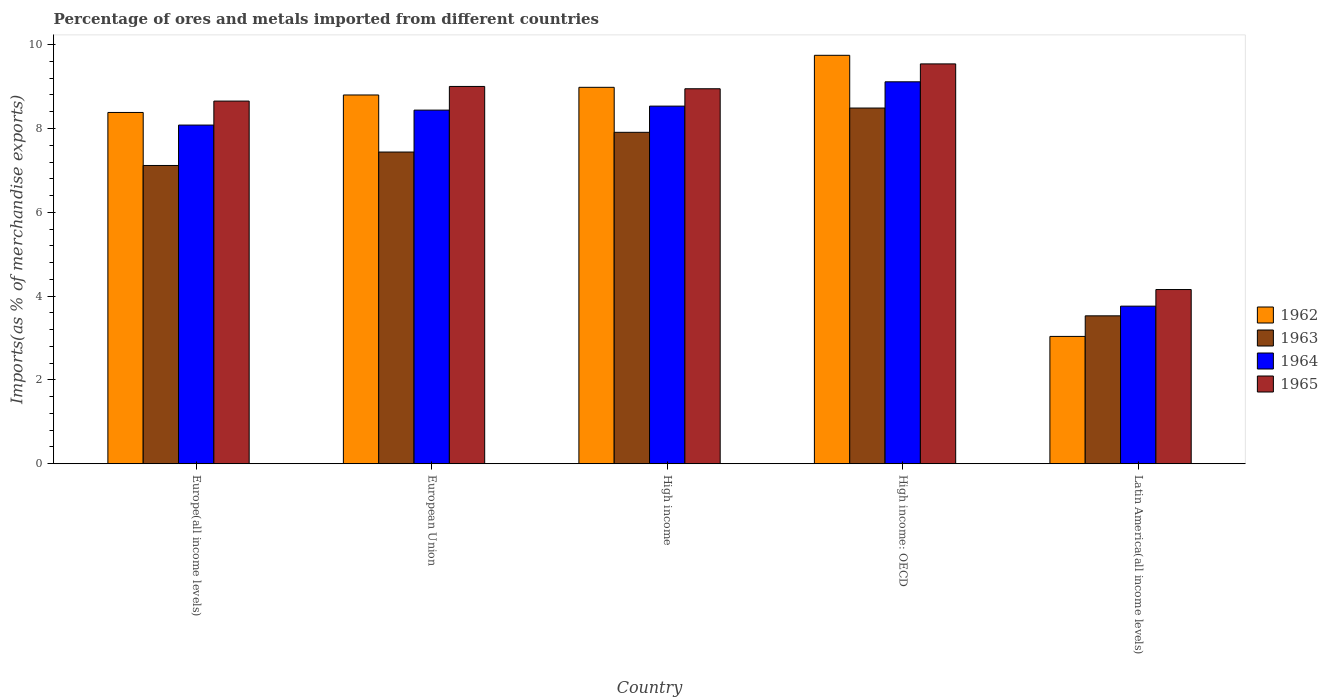How many groups of bars are there?
Offer a terse response. 5. Are the number of bars per tick equal to the number of legend labels?
Keep it short and to the point. Yes. How many bars are there on the 2nd tick from the left?
Provide a succinct answer. 4. How many bars are there on the 2nd tick from the right?
Your answer should be very brief. 4. What is the label of the 4th group of bars from the left?
Provide a succinct answer. High income: OECD. In how many cases, is the number of bars for a given country not equal to the number of legend labels?
Provide a short and direct response. 0. What is the percentage of imports to different countries in 1963 in Europe(all income levels)?
Provide a succinct answer. 7.12. Across all countries, what is the maximum percentage of imports to different countries in 1962?
Offer a terse response. 9.75. Across all countries, what is the minimum percentage of imports to different countries in 1963?
Your response must be concise. 3.53. In which country was the percentage of imports to different countries in 1965 maximum?
Make the answer very short. High income: OECD. In which country was the percentage of imports to different countries in 1963 minimum?
Keep it short and to the point. Latin America(all income levels). What is the total percentage of imports to different countries in 1962 in the graph?
Offer a terse response. 38.95. What is the difference between the percentage of imports to different countries in 1965 in European Union and that in High income: OECD?
Provide a succinct answer. -0.54. What is the difference between the percentage of imports to different countries in 1963 in Latin America(all income levels) and the percentage of imports to different countries in 1964 in European Union?
Keep it short and to the point. -4.91. What is the average percentage of imports to different countries in 1965 per country?
Offer a very short reply. 8.06. What is the difference between the percentage of imports to different countries of/in 1965 and percentage of imports to different countries of/in 1964 in Europe(all income levels)?
Offer a terse response. 0.57. In how many countries, is the percentage of imports to different countries in 1962 greater than 9.2 %?
Your answer should be very brief. 1. What is the ratio of the percentage of imports to different countries in 1963 in High income to that in High income: OECD?
Keep it short and to the point. 0.93. Is the percentage of imports to different countries in 1965 in High income: OECD less than that in Latin America(all income levels)?
Your answer should be very brief. No. Is the difference between the percentage of imports to different countries in 1965 in Europe(all income levels) and High income greater than the difference between the percentage of imports to different countries in 1964 in Europe(all income levels) and High income?
Provide a short and direct response. Yes. What is the difference between the highest and the second highest percentage of imports to different countries in 1964?
Keep it short and to the point. -0.58. What is the difference between the highest and the lowest percentage of imports to different countries in 1964?
Provide a short and direct response. 5.35. In how many countries, is the percentage of imports to different countries in 1962 greater than the average percentage of imports to different countries in 1962 taken over all countries?
Give a very brief answer. 4. Is it the case that in every country, the sum of the percentage of imports to different countries in 1965 and percentage of imports to different countries in 1964 is greater than the sum of percentage of imports to different countries in 1963 and percentage of imports to different countries in 1962?
Give a very brief answer. No. What does the 4th bar from the left in High income: OECD represents?
Ensure brevity in your answer.  1965. What does the 3rd bar from the right in Latin America(all income levels) represents?
Your response must be concise. 1963. Is it the case that in every country, the sum of the percentage of imports to different countries in 1963 and percentage of imports to different countries in 1965 is greater than the percentage of imports to different countries in 1962?
Provide a succinct answer. Yes. How many bars are there?
Give a very brief answer. 20. Are all the bars in the graph horizontal?
Ensure brevity in your answer.  No. How many countries are there in the graph?
Make the answer very short. 5. What is the difference between two consecutive major ticks on the Y-axis?
Offer a terse response. 2. Does the graph contain grids?
Ensure brevity in your answer.  No. Where does the legend appear in the graph?
Offer a very short reply. Center right. How are the legend labels stacked?
Your answer should be compact. Vertical. What is the title of the graph?
Make the answer very short. Percentage of ores and metals imported from different countries. Does "1990" appear as one of the legend labels in the graph?
Provide a short and direct response. No. What is the label or title of the Y-axis?
Offer a very short reply. Imports(as % of merchandise exports). What is the Imports(as % of merchandise exports) in 1962 in Europe(all income levels)?
Keep it short and to the point. 8.38. What is the Imports(as % of merchandise exports) of 1963 in Europe(all income levels)?
Your answer should be very brief. 7.12. What is the Imports(as % of merchandise exports) of 1964 in Europe(all income levels)?
Offer a very short reply. 8.08. What is the Imports(as % of merchandise exports) in 1965 in Europe(all income levels)?
Offer a very short reply. 8.65. What is the Imports(as % of merchandise exports) in 1962 in European Union?
Ensure brevity in your answer.  8.8. What is the Imports(as % of merchandise exports) of 1963 in European Union?
Give a very brief answer. 7.44. What is the Imports(as % of merchandise exports) of 1964 in European Union?
Provide a succinct answer. 8.44. What is the Imports(as % of merchandise exports) in 1965 in European Union?
Make the answer very short. 9. What is the Imports(as % of merchandise exports) in 1962 in High income?
Your response must be concise. 8.98. What is the Imports(as % of merchandise exports) in 1963 in High income?
Ensure brevity in your answer.  7.91. What is the Imports(as % of merchandise exports) of 1964 in High income?
Provide a succinct answer. 8.53. What is the Imports(as % of merchandise exports) in 1965 in High income?
Keep it short and to the point. 8.95. What is the Imports(as % of merchandise exports) of 1962 in High income: OECD?
Keep it short and to the point. 9.75. What is the Imports(as % of merchandise exports) of 1963 in High income: OECD?
Keep it short and to the point. 8.49. What is the Imports(as % of merchandise exports) of 1964 in High income: OECD?
Offer a terse response. 9.11. What is the Imports(as % of merchandise exports) in 1965 in High income: OECD?
Provide a short and direct response. 9.54. What is the Imports(as % of merchandise exports) in 1962 in Latin America(all income levels)?
Provide a short and direct response. 3.04. What is the Imports(as % of merchandise exports) in 1963 in Latin America(all income levels)?
Make the answer very short. 3.53. What is the Imports(as % of merchandise exports) of 1964 in Latin America(all income levels)?
Provide a succinct answer. 3.76. What is the Imports(as % of merchandise exports) in 1965 in Latin America(all income levels)?
Your answer should be very brief. 4.16. Across all countries, what is the maximum Imports(as % of merchandise exports) of 1962?
Offer a very short reply. 9.75. Across all countries, what is the maximum Imports(as % of merchandise exports) of 1963?
Offer a terse response. 8.49. Across all countries, what is the maximum Imports(as % of merchandise exports) in 1964?
Offer a terse response. 9.11. Across all countries, what is the maximum Imports(as % of merchandise exports) in 1965?
Make the answer very short. 9.54. Across all countries, what is the minimum Imports(as % of merchandise exports) of 1962?
Provide a succinct answer. 3.04. Across all countries, what is the minimum Imports(as % of merchandise exports) of 1963?
Provide a succinct answer. 3.53. Across all countries, what is the minimum Imports(as % of merchandise exports) in 1964?
Your response must be concise. 3.76. Across all countries, what is the minimum Imports(as % of merchandise exports) of 1965?
Provide a short and direct response. 4.16. What is the total Imports(as % of merchandise exports) of 1962 in the graph?
Provide a short and direct response. 38.95. What is the total Imports(as % of merchandise exports) in 1963 in the graph?
Make the answer very short. 34.48. What is the total Imports(as % of merchandise exports) of 1964 in the graph?
Provide a succinct answer. 37.93. What is the total Imports(as % of merchandise exports) of 1965 in the graph?
Offer a very short reply. 40.31. What is the difference between the Imports(as % of merchandise exports) of 1962 in Europe(all income levels) and that in European Union?
Keep it short and to the point. -0.42. What is the difference between the Imports(as % of merchandise exports) in 1963 in Europe(all income levels) and that in European Union?
Ensure brevity in your answer.  -0.32. What is the difference between the Imports(as % of merchandise exports) of 1964 in Europe(all income levels) and that in European Union?
Provide a short and direct response. -0.36. What is the difference between the Imports(as % of merchandise exports) in 1965 in Europe(all income levels) and that in European Union?
Keep it short and to the point. -0.35. What is the difference between the Imports(as % of merchandise exports) in 1962 in Europe(all income levels) and that in High income?
Offer a very short reply. -0.6. What is the difference between the Imports(as % of merchandise exports) of 1963 in Europe(all income levels) and that in High income?
Ensure brevity in your answer.  -0.79. What is the difference between the Imports(as % of merchandise exports) in 1964 in Europe(all income levels) and that in High income?
Offer a terse response. -0.45. What is the difference between the Imports(as % of merchandise exports) in 1965 in Europe(all income levels) and that in High income?
Provide a short and direct response. -0.29. What is the difference between the Imports(as % of merchandise exports) of 1962 in Europe(all income levels) and that in High income: OECD?
Your answer should be compact. -1.36. What is the difference between the Imports(as % of merchandise exports) in 1963 in Europe(all income levels) and that in High income: OECD?
Provide a succinct answer. -1.37. What is the difference between the Imports(as % of merchandise exports) of 1964 in Europe(all income levels) and that in High income: OECD?
Provide a succinct answer. -1.03. What is the difference between the Imports(as % of merchandise exports) of 1965 in Europe(all income levels) and that in High income: OECD?
Keep it short and to the point. -0.89. What is the difference between the Imports(as % of merchandise exports) of 1962 in Europe(all income levels) and that in Latin America(all income levels)?
Give a very brief answer. 5.34. What is the difference between the Imports(as % of merchandise exports) in 1963 in Europe(all income levels) and that in Latin America(all income levels)?
Make the answer very short. 3.59. What is the difference between the Imports(as % of merchandise exports) in 1964 in Europe(all income levels) and that in Latin America(all income levels)?
Give a very brief answer. 4.32. What is the difference between the Imports(as % of merchandise exports) in 1965 in Europe(all income levels) and that in Latin America(all income levels)?
Provide a succinct answer. 4.5. What is the difference between the Imports(as % of merchandise exports) in 1962 in European Union and that in High income?
Keep it short and to the point. -0.18. What is the difference between the Imports(as % of merchandise exports) in 1963 in European Union and that in High income?
Give a very brief answer. -0.47. What is the difference between the Imports(as % of merchandise exports) in 1964 in European Union and that in High income?
Offer a very short reply. -0.1. What is the difference between the Imports(as % of merchandise exports) in 1965 in European Union and that in High income?
Make the answer very short. 0.06. What is the difference between the Imports(as % of merchandise exports) of 1962 in European Union and that in High income: OECD?
Offer a very short reply. -0.95. What is the difference between the Imports(as % of merchandise exports) in 1963 in European Union and that in High income: OECD?
Offer a terse response. -1.05. What is the difference between the Imports(as % of merchandise exports) in 1964 in European Union and that in High income: OECD?
Make the answer very short. -0.68. What is the difference between the Imports(as % of merchandise exports) in 1965 in European Union and that in High income: OECD?
Give a very brief answer. -0.54. What is the difference between the Imports(as % of merchandise exports) of 1962 in European Union and that in Latin America(all income levels)?
Make the answer very short. 5.76. What is the difference between the Imports(as % of merchandise exports) in 1963 in European Union and that in Latin America(all income levels)?
Make the answer very short. 3.91. What is the difference between the Imports(as % of merchandise exports) of 1964 in European Union and that in Latin America(all income levels)?
Offer a very short reply. 4.68. What is the difference between the Imports(as % of merchandise exports) in 1965 in European Union and that in Latin America(all income levels)?
Ensure brevity in your answer.  4.85. What is the difference between the Imports(as % of merchandise exports) of 1962 in High income and that in High income: OECD?
Your answer should be very brief. -0.76. What is the difference between the Imports(as % of merchandise exports) in 1963 in High income and that in High income: OECD?
Your answer should be compact. -0.58. What is the difference between the Imports(as % of merchandise exports) in 1964 in High income and that in High income: OECD?
Keep it short and to the point. -0.58. What is the difference between the Imports(as % of merchandise exports) of 1965 in High income and that in High income: OECD?
Offer a terse response. -0.59. What is the difference between the Imports(as % of merchandise exports) in 1962 in High income and that in Latin America(all income levels)?
Keep it short and to the point. 5.94. What is the difference between the Imports(as % of merchandise exports) of 1963 in High income and that in Latin America(all income levels)?
Make the answer very short. 4.38. What is the difference between the Imports(as % of merchandise exports) in 1964 in High income and that in Latin America(all income levels)?
Give a very brief answer. 4.77. What is the difference between the Imports(as % of merchandise exports) in 1965 in High income and that in Latin America(all income levels)?
Make the answer very short. 4.79. What is the difference between the Imports(as % of merchandise exports) in 1962 in High income: OECD and that in Latin America(all income levels)?
Your answer should be very brief. 6.71. What is the difference between the Imports(as % of merchandise exports) in 1963 in High income: OECD and that in Latin America(all income levels)?
Your response must be concise. 4.96. What is the difference between the Imports(as % of merchandise exports) of 1964 in High income: OECD and that in Latin America(all income levels)?
Your response must be concise. 5.35. What is the difference between the Imports(as % of merchandise exports) of 1965 in High income: OECD and that in Latin America(all income levels)?
Keep it short and to the point. 5.38. What is the difference between the Imports(as % of merchandise exports) in 1962 in Europe(all income levels) and the Imports(as % of merchandise exports) in 1963 in European Union?
Keep it short and to the point. 0.94. What is the difference between the Imports(as % of merchandise exports) in 1962 in Europe(all income levels) and the Imports(as % of merchandise exports) in 1964 in European Union?
Provide a succinct answer. -0.06. What is the difference between the Imports(as % of merchandise exports) of 1962 in Europe(all income levels) and the Imports(as % of merchandise exports) of 1965 in European Union?
Your answer should be very brief. -0.62. What is the difference between the Imports(as % of merchandise exports) of 1963 in Europe(all income levels) and the Imports(as % of merchandise exports) of 1964 in European Union?
Ensure brevity in your answer.  -1.32. What is the difference between the Imports(as % of merchandise exports) in 1963 in Europe(all income levels) and the Imports(as % of merchandise exports) in 1965 in European Union?
Your response must be concise. -1.89. What is the difference between the Imports(as % of merchandise exports) of 1964 in Europe(all income levels) and the Imports(as % of merchandise exports) of 1965 in European Union?
Provide a succinct answer. -0.92. What is the difference between the Imports(as % of merchandise exports) of 1962 in Europe(all income levels) and the Imports(as % of merchandise exports) of 1963 in High income?
Your answer should be compact. 0.47. What is the difference between the Imports(as % of merchandise exports) in 1962 in Europe(all income levels) and the Imports(as % of merchandise exports) in 1964 in High income?
Keep it short and to the point. -0.15. What is the difference between the Imports(as % of merchandise exports) of 1962 in Europe(all income levels) and the Imports(as % of merchandise exports) of 1965 in High income?
Provide a succinct answer. -0.57. What is the difference between the Imports(as % of merchandise exports) in 1963 in Europe(all income levels) and the Imports(as % of merchandise exports) in 1964 in High income?
Ensure brevity in your answer.  -1.42. What is the difference between the Imports(as % of merchandise exports) of 1963 in Europe(all income levels) and the Imports(as % of merchandise exports) of 1965 in High income?
Offer a very short reply. -1.83. What is the difference between the Imports(as % of merchandise exports) of 1964 in Europe(all income levels) and the Imports(as % of merchandise exports) of 1965 in High income?
Give a very brief answer. -0.87. What is the difference between the Imports(as % of merchandise exports) in 1962 in Europe(all income levels) and the Imports(as % of merchandise exports) in 1963 in High income: OECD?
Your answer should be compact. -0.11. What is the difference between the Imports(as % of merchandise exports) of 1962 in Europe(all income levels) and the Imports(as % of merchandise exports) of 1964 in High income: OECD?
Make the answer very short. -0.73. What is the difference between the Imports(as % of merchandise exports) in 1962 in Europe(all income levels) and the Imports(as % of merchandise exports) in 1965 in High income: OECD?
Provide a short and direct response. -1.16. What is the difference between the Imports(as % of merchandise exports) of 1963 in Europe(all income levels) and the Imports(as % of merchandise exports) of 1964 in High income: OECD?
Provide a succinct answer. -2. What is the difference between the Imports(as % of merchandise exports) in 1963 in Europe(all income levels) and the Imports(as % of merchandise exports) in 1965 in High income: OECD?
Make the answer very short. -2.42. What is the difference between the Imports(as % of merchandise exports) in 1964 in Europe(all income levels) and the Imports(as % of merchandise exports) in 1965 in High income: OECD?
Your answer should be very brief. -1.46. What is the difference between the Imports(as % of merchandise exports) in 1962 in Europe(all income levels) and the Imports(as % of merchandise exports) in 1963 in Latin America(all income levels)?
Give a very brief answer. 4.85. What is the difference between the Imports(as % of merchandise exports) in 1962 in Europe(all income levels) and the Imports(as % of merchandise exports) in 1964 in Latin America(all income levels)?
Ensure brevity in your answer.  4.62. What is the difference between the Imports(as % of merchandise exports) in 1962 in Europe(all income levels) and the Imports(as % of merchandise exports) in 1965 in Latin America(all income levels)?
Your response must be concise. 4.23. What is the difference between the Imports(as % of merchandise exports) in 1963 in Europe(all income levels) and the Imports(as % of merchandise exports) in 1964 in Latin America(all income levels)?
Your answer should be compact. 3.36. What is the difference between the Imports(as % of merchandise exports) of 1963 in Europe(all income levels) and the Imports(as % of merchandise exports) of 1965 in Latin America(all income levels)?
Make the answer very short. 2.96. What is the difference between the Imports(as % of merchandise exports) of 1964 in Europe(all income levels) and the Imports(as % of merchandise exports) of 1965 in Latin America(all income levels)?
Offer a very short reply. 3.92. What is the difference between the Imports(as % of merchandise exports) in 1962 in European Union and the Imports(as % of merchandise exports) in 1963 in High income?
Your response must be concise. 0.89. What is the difference between the Imports(as % of merchandise exports) of 1962 in European Union and the Imports(as % of merchandise exports) of 1964 in High income?
Offer a very short reply. 0.27. What is the difference between the Imports(as % of merchandise exports) in 1962 in European Union and the Imports(as % of merchandise exports) in 1965 in High income?
Your answer should be very brief. -0.15. What is the difference between the Imports(as % of merchandise exports) in 1963 in European Union and the Imports(as % of merchandise exports) in 1964 in High income?
Give a very brief answer. -1.1. What is the difference between the Imports(as % of merchandise exports) in 1963 in European Union and the Imports(as % of merchandise exports) in 1965 in High income?
Give a very brief answer. -1.51. What is the difference between the Imports(as % of merchandise exports) of 1964 in European Union and the Imports(as % of merchandise exports) of 1965 in High income?
Offer a terse response. -0.51. What is the difference between the Imports(as % of merchandise exports) of 1962 in European Union and the Imports(as % of merchandise exports) of 1963 in High income: OECD?
Make the answer very short. 0.31. What is the difference between the Imports(as % of merchandise exports) in 1962 in European Union and the Imports(as % of merchandise exports) in 1964 in High income: OECD?
Your response must be concise. -0.31. What is the difference between the Imports(as % of merchandise exports) in 1962 in European Union and the Imports(as % of merchandise exports) in 1965 in High income: OECD?
Provide a short and direct response. -0.74. What is the difference between the Imports(as % of merchandise exports) in 1963 in European Union and the Imports(as % of merchandise exports) in 1964 in High income: OECD?
Your answer should be compact. -1.68. What is the difference between the Imports(as % of merchandise exports) in 1963 in European Union and the Imports(as % of merchandise exports) in 1965 in High income: OECD?
Provide a succinct answer. -2.1. What is the difference between the Imports(as % of merchandise exports) of 1964 in European Union and the Imports(as % of merchandise exports) of 1965 in High income: OECD?
Provide a succinct answer. -1.1. What is the difference between the Imports(as % of merchandise exports) of 1962 in European Union and the Imports(as % of merchandise exports) of 1963 in Latin America(all income levels)?
Give a very brief answer. 5.27. What is the difference between the Imports(as % of merchandise exports) in 1962 in European Union and the Imports(as % of merchandise exports) in 1964 in Latin America(all income levels)?
Keep it short and to the point. 5.04. What is the difference between the Imports(as % of merchandise exports) of 1962 in European Union and the Imports(as % of merchandise exports) of 1965 in Latin America(all income levels)?
Your answer should be very brief. 4.64. What is the difference between the Imports(as % of merchandise exports) in 1963 in European Union and the Imports(as % of merchandise exports) in 1964 in Latin America(all income levels)?
Ensure brevity in your answer.  3.68. What is the difference between the Imports(as % of merchandise exports) in 1963 in European Union and the Imports(as % of merchandise exports) in 1965 in Latin America(all income levels)?
Your answer should be compact. 3.28. What is the difference between the Imports(as % of merchandise exports) in 1964 in European Union and the Imports(as % of merchandise exports) in 1965 in Latin America(all income levels)?
Ensure brevity in your answer.  4.28. What is the difference between the Imports(as % of merchandise exports) of 1962 in High income and the Imports(as % of merchandise exports) of 1963 in High income: OECD?
Your answer should be very brief. 0.49. What is the difference between the Imports(as % of merchandise exports) in 1962 in High income and the Imports(as % of merchandise exports) in 1964 in High income: OECD?
Provide a succinct answer. -0.13. What is the difference between the Imports(as % of merchandise exports) of 1962 in High income and the Imports(as % of merchandise exports) of 1965 in High income: OECD?
Provide a short and direct response. -0.56. What is the difference between the Imports(as % of merchandise exports) of 1963 in High income and the Imports(as % of merchandise exports) of 1964 in High income: OECD?
Ensure brevity in your answer.  -1.21. What is the difference between the Imports(as % of merchandise exports) of 1963 in High income and the Imports(as % of merchandise exports) of 1965 in High income: OECD?
Give a very brief answer. -1.63. What is the difference between the Imports(as % of merchandise exports) in 1964 in High income and the Imports(as % of merchandise exports) in 1965 in High income: OECD?
Ensure brevity in your answer.  -1.01. What is the difference between the Imports(as % of merchandise exports) of 1962 in High income and the Imports(as % of merchandise exports) of 1963 in Latin America(all income levels)?
Your response must be concise. 5.45. What is the difference between the Imports(as % of merchandise exports) in 1962 in High income and the Imports(as % of merchandise exports) in 1964 in Latin America(all income levels)?
Your answer should be compact. 5.22. What is the difference between the Imports(as % of merchandise exports) of 1962 in High income and the Imports(as % of merchandise exports) of 1965 in Latin America(all income levels)?
Make the answer very short. 4.83. What is the difference between the Imports(as % of merchandise exports) of 1963 in High income and the Imports(as % of merchandise exports) of 1964 in Latin America(all income levels)?
Your response must be concise. 4.15. What is the difference between the Imports(as % of merchandise exports) of 1963 in High income and the Imports(as % of merchandise exports) of 1965 in Latin America(all income levels)?
Your response must be concise. 3.75. What is the difference between the Imports(as % of merchandise exports) in 1964 in High income and the Imports(as % of merchandise exports) in 1965 in Latin America(all income levels)?
Keep it short and to the point. 4.38. What is the difference between the Imports(as % of merchandise exports) in 1962 in High income: OECD and the Imports(as % of merchandise exports) in 1963 in Latin America(all income levels)?
Give a very brief answer. 6.22. What is the difference between the Imports(as % of merchandise exports) of 1962 in High income: OECD and the Imports(as % of merchandise exports) of 1964 in Latin America(all income levels)?
Ensure brevity in your answer.  5.99. What is the difference between the Imports(as % of merchandise exports) of 1962 in High income: OECD and the Imports(as % of merchandise exports) of 1965 in Latin America(all income levels)?
Your answer should be very brief. 5.59. What is the difference between the Imports(as % of merchandise exports) of 1963 in High income: OECD and the Imports(as % of merchandise exports) of 1964 in Latin America(all income levels)?
Provide a short and direct response. 4.73. What is the difference between the Imports(as % of merchandise exports) of 1963 in High income: OECD and the Imports(as % of merchandise exports) of 1965 in Latin America(all income levels)?
Your response must be concise. 4.33. What is the difference between the Imports(as % of merchandise exports) of 1964 in High income: OECD and the Imports(as % of merchandise exports) of 1965 in Latin America(all income levels)?
Provide a short and direct response. 4.96. What is the average Imports(as % of merchandise exports) of 1962 per country?
Provide a short and direct response. 7.79. What is the average Imports(as % of merchandise exports) of 1963 per country?
Your response must be concise. 6.9. What is the average Imports(as % of merchandise exports) of 1964 per country?
Provide a short and direct response. 7.59. What is the average Imports(as % of merchandise exports) of 1965 per country?
Give a very brief answer. 8.06. What is the difference between the Imports(as % of merchandise exports) in 1962 and Imports(as % of merchandise exports) in 1963 in Europe(all income levels)?
Offer a terse response. 1.26. What is the difference between the Imports(as % of merchandise exports) in 1962 and Imports(as % of merchandise exports) in 1964 in Europe(all income levels)?
Make the answer very short. 0.3. What is the difference between the Imports(as % of merchandise exports) of 1962 and Imports(as % of merchandise exports) of 1965 in Europe(all income levels)?
Offer a terse response. -0.27. What is the difference between the Imports(as % of merchandise exports) in 1963 and Imports(as % of merchandise exports) in 1964 in Europe(all income levels)?
Give a very brief answer. -0.96. What is the difference between the Imports(as % of merchandise exports) in 1963 and Imports(as % of merchandise exports) in 1965 in Europe(all income levels)?
Your answer should be compact. -1.54. What is the difference between the Imports(as % of merchandise exports) of 1964 and Imports(as % of merchandise exports) of 1965 in Europe(all income levels)?
Your response must be concise. -0.57. What is the difference between the Imports(as % of merchandise exports) of 1962 and Imports(as % of merchandise exports) of 1963 in European Union?
Ensure brevity in your answer.  1.36. What is the difference between the Imports(as % of merchandise exports) of 1962 and Imports(as % of merchandise exports) of 1964 in European Union?
Keep it short and to the point. 0.36. What is the difference between the Imports(as % of merchandise exports) in 1962 and Imports(as % of merchandise exports) in 1965 in European Union?
Make the answer very short. -0.2. What is the difference between the Imports(as % of merchandise exports) in 1963 and Imports(as % of merchandise exports) in 1964 in European Union?
Ensure brevity in your answer.  -1. What is the difference between the Imports(as % of merchandise exports) in 1963 and Imports(as % of merchandise exports) in 1965 in European Union?
Your answer should be very brief. -1.57. What is the difference between the Imports(as % of merchandise exports) in 1964 and Imports(as % of merchandise exports) in 1965 in European Union?
Provide a succinct answer. -0.56. What is the difference between the Imports(as % of merchandise exports) in 1962 and Imports(as % of merchandise exports) in 1963 in High income?
Make the answer very short. 1.07. What is the difference between the Imports(as % of merchandise exports) in 1962 and Imports(as % of merchandise exports) in 1964 in High income?
Make the answer very short. 0.45. What is the difference between the Imports(as % of merchandise exports) of 1962 and Imports(as % of merchandise exports) of 1965 in High income?
Offer a very short reply. 0.03. What is the difference between the Imports(as % of merchandise exports) in 1963 and Imports(as % of merchandise exports) in 1964 in High income?
Your response must be concise. -0.63. What is the difference between the Imports(as % of merchandise exports) of 1963 and Imports(as % of merchandise exports) of 1965 in High income?
Make the answer very short. -1.04. What is the difference between the Imports(as % of merchandise exports) of 1964 and Imports(as % of merchandise exports) of 1965 in High income?
Offer a very short reply. -0.41. What is the difference between the Imports(as % of merchandise exports) in 1962 and Imports(as % of merchandise exports) in 1963 in High income: OECD?
Provide a short and direct response. 1.26. What is the difference between the Imports(as % of merchandise exports) in 1962 and Imports(as % of merchandise exports) in 1964 in High income: OECD?
Keep it short and to the point. 0.63. What is the difference between the Imports(as % of merchandise exports) of 1962 and Imports(as % of merchandise exports) of 1965 in High income: OECD?
Ensure brevity in your answer.  0.21. What is the difference between the Imports(as % of merchandise exports) in 1963 and Imports(as % of merchandise exports) in 1964 in High income: OECD?
Provide a short and direct response. -0.63. What is the difference between the Imports(as % of merchandise exports) of 1963 and Imports(as % of merchandise exports) of 1965 in High income: OECD?
Offer a terse response. -1.05. What is the difference between the Imports(as % of merchandise exports) of 1964 and Imports(as % of merchandise exports) of 1965 in High income: OECD?
Make the answer very short. -0.43. What is the difference between the Imports(as % of merchandise exports) of 1962 and Imports(as % of merchandise exports) of 1963 in Latin America(all income levels)?
Your answer should be compact. -0.49. What is the difference between the Imports(as % of merchandise exports) of 1962 and Imports(as % of merchandise exports) of 1964 in Latin America(all income levels)?
Your answer should be very brief. -0.72. What is the difference between the Imports(as % of merchandise exports) in 1962 and Imports(as % of merchandise exports) in 1965 in Latin America(all income levels)?
Ensure brevity in your answer.  -1.12. What is the difference between the Imports(as % of merchandise exports) of 1963 and Imports(as % of merchandise exports) of 1964 in Latin America(all income levels)?
Provide a short and direct response. -0.23. What is the difference between the Imports(as % of merchandise exports) in 1963 and Imports(as % of merchandise exports) in 1965 in Latin America(all income levels)?
Your answer should be compact. -0.63. What is the difference between the Imports(as % of merchandise exports) in 1964 and Imports(as % of merchandise exports) in 1965 in Latin America(all income levels)?
Keep it short and to the point. -0.4. What is the ratio of the Imports(as % of merchandise exports) in 1962 in Europe(all income levels) to that in European Union?
Offer a very short reply. 0.95. What is the ratio of the Imports(as % of merchandise exports) of 1963 in Europe(all income levels) to that in European Union?
Ensure brevity in your answer.  0.96. What is the ratio of the Imports(as % of merchandise exports) of 1964 in Europe(all income levels) to that in European Union?
Provide a short and direct response. 0.96. What is the ratio of the Imports(as % of merchandise exports) of 1965 in Europe(all income levels) to that in European Union?
Your response must be concise. 0.96. What is the ratio of the Imports(as % of merchandise exports) in 1962 in Europe(all income levels) to that in High income?
Offer a very short reply. 0.93. What is the ratio of the Imports(as % of merchandise exports) of 1963 in Europe(all income levels) to that in High income?
Your response must be concise. 0.9. What is the ratio of the Imports(as % of merchandise exports) of 1964 in Europe(all income levels) to that in High income?
Your response must be concise. 0.95. What is the ratio of the Imports(as % of merchandise exports) in 1965 in Europe(all income levels) to that in High income?
Provide a short and direct response. 0.97. What is the ratio of the Imports(as % of merchandise exports) in 1962 in Europe(all income levels) to that in High income: OECD?
Keep it short and to the point. 0.86. What is the ratio of the Imports(as % of merchandise exports) in 1963 in Europe(all income levels) to that in High income: OECD?
Give a very brief answer. 0.84. What is the ratio of the Imports(as % of merchandise exports) of 1964 in Europe(all income levels) to that in High income: OECD?
Offer a terse response. 0.89. What is the ratio of the Imports(as % of merchandise exports) of 1965 in Europe(all income levels) to that in High income: OECD?
Your answer should be compact. 0.91. What is the ratio of the Imports(as % of merchandise exports) in 1962 in Europe(all income levels) to that in Latin America(all income levels)?
Your answer should be compact. 2.76. What is the ratio of the Imports(as % of merchandise exports) in 1963 in Europe(all income levels) to that in Latin America(all income levels)?
Ensure brevity in your answer.  2.02. What is the ratio of the Imports(as % of merchandise exports) in 1964 in Europe(all income levels) to that in Latin America(all income levels)?
Make the answer very short. 2.15. What is the ratio of the Imports(as % of merchandise exports) of 1965 in Europe(all income levels) to that in Latin America(all income levels)?
Keep it short and to the point. 2.08. What is the ratio of the Imports(as % of merchandise exports) of 1962 in European Union to that in High income?
Your answer should be compact. 0.98. What is the ratio of the Imports(as % of merchandise exports) in 1963 in European Union to that in High income?
Your answer should be very brief. 0.94. What is the ratio of the Imports(as % of merchandise exports) of 1964 in European Union to that in High income?
Offer a very short reply. 0.99. What is the ratio of the Imports(as % of merchandise exports) of 1965 in European Union to that in High income?
Provide a succinct answer. 1.01. What is the ratio of the Imports(as % of merchandise exports) in 1962 in European Union to that in High income: OECD?
Your answer should be compact. 0.9. What is the ratio of the Imports(as % of merchandise exports) in 1963 in European Union to that in High income: OECD?
Ensure brevity in your answer.  0.88. What is the ratio of the Imports(as % of merchandise exports) in 1964 in European Union to that in High income: OECD?
Offer a very short reply. 0.93. What is the ratio of the Imports(as % of merchandise exports) of 1965 in European Union to that in High income: OECD?
Provide a short and direct response. 0.94. What is the ratio of the Imports(as % of merchandise exports) in 1962 in European Union to that in Latin America(all income levels)?
Make the answer very short. 2.9. What is the ratio of the Imports(as % of merchandise exports) in 1963 in European Union to that in Latin America(all income levels)?
Your answer should be very brief. 2.11. What is the ratio of the Imports(as % of merchandise exports) of 1964 in European Union to that in Latin America(all income levels)?
Your response must be concise. 2.24. What is the ratio of the Imports(as % of merchandise exports) of 1965 in European Union to that in Latin America(all income levels)?
Provide a short and direct response. 2.17. What is the ratio of the Imports(as % of merchandise exports) in 1962 in High income to that in High income: OECD?
Your response must be concise. 0.92. What is the ratio of the Imports(as % of merchandise exports) in 1963 in High income to that in High income: OECD?
Provide a short and direct response. 0.93. What is the ratio of the Imports(as % of merchandise exports) of 1964 in High income to that in High income: OECD?
Your response must be concise. 0.94. What is the ratio of the Imports(as % of merchandise exports) in 1965 in High income to that in High income: OECD?
Provide a succinct answer. 0.94. What is the ratio of the Imports(as % of merchandise exports) of 1962 in High income to that in Latin America(all income levels)?
Offer a terse response. 2.96. What is the ratio of the Imports(as % of merchandise exports) in 1963 in High income to that in Latin America(all income levels)?
Your answer should be compact. 2.24. What is the ratio of the Imports(as % of merchandise exports) in 1964 in High income to that in Latin America(all income levels)?
Provide a short and direct response. 2.27. What is the ratio of the Imports(as % of merchandise exports) of 1965 in High income to that in Latin America(all income levels)?
Ensure brevity in your answer.  2.15. What is the ratio of the Imports(as % of merchandise exports) in 1962 in High income: OECD to that in Latin America(all income levels)?
Ensure brevity in your answer.  3.21. What is the ratio of the Imports(as % of merchandise exports) of 1963 in High income: OECD to that in Latin America(all income levels)?
Provide a succinct answer. 2.4. What is the ratio of the Imports(as % of merchandise exports) of 1964 in High income: OECD to that in Latin America(all income levels)?
Keep it short and to the point. 2.42. What is the ratio of the Imports(as % of merchandise exports) of 1965 in High income: OECD to that in Latin America(all income levels)?
Provide a succinct answer. 2.3. What is the difference between the highest and the second highest Imports(as % of merchandise exports) in 1962?
Provide a succinct answer. 0.76. What is the difference between the highest and the second highest Imports(as % of merchandise exports) of 1963?
Provide a succinct answer. 0.58. What is the difference between the highest and the second highest Imports(as % of merchandise exports) of 1964?
Your response must be concise. 0.58. What is the difference between the highest and the second highest Imports(as % of merchandise exports) of 1965?
Offer a terse response. 0.54. What is the difference between the highest and the lowest Imports(as % of merchandise exports) in 1962?
Provide a succinct answer. 6.71. What is the difference between the highest and the lowest Imports(as % of merchandise exports) of 1963?
Give a very brief answer. 4.96. What is the difference between the highest and the lowest Imports(as % of merchandise exports) in 1964?
Keep it short and to the point. 5.35. What is the difference between the highest and the lowest Imports(as % of merchandise exports) in 1965?
Give a very brief answer. 5.38. 